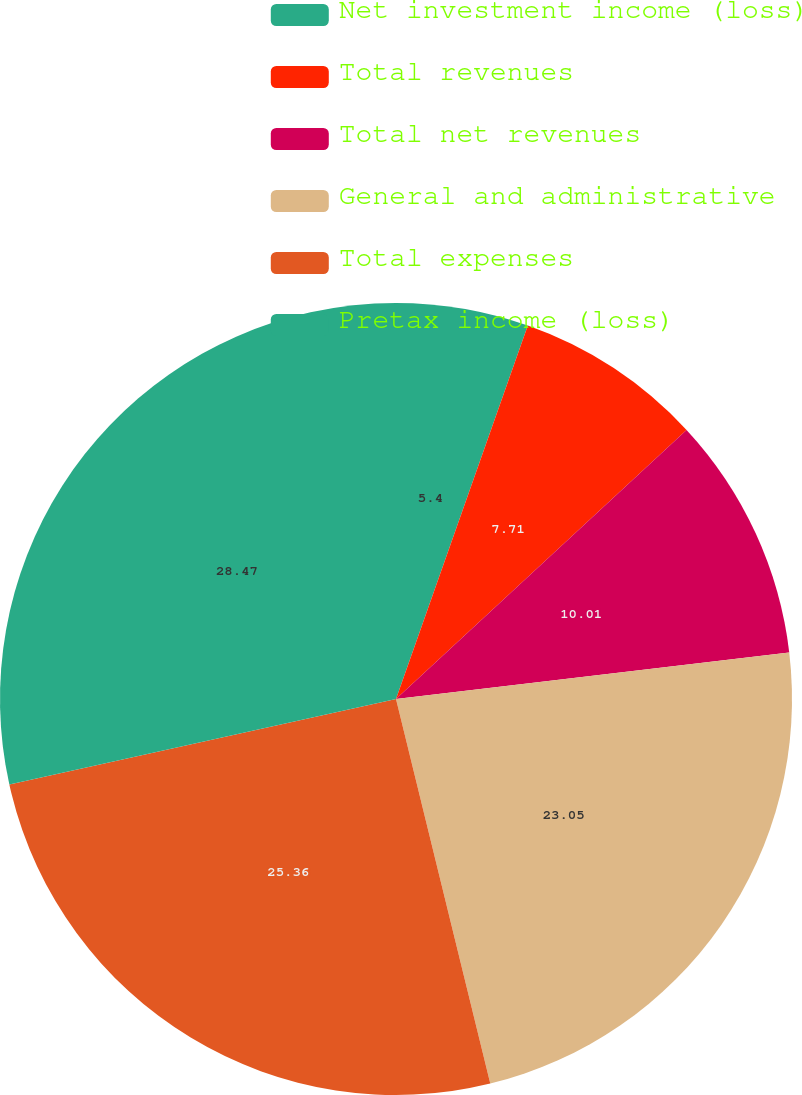Convert chart to OTSL. <chart><loc_0><loc_0><loc_500><loc_500><pie_chart><fcel>Net investment income (loss)<fcel>Total revenues<fcel>Total net revenues<fcel>General and administrative<fcel>Total expenses<fcel>Pretax income (loss)<nl><fcel>5.4%<fcel>7.71%<fcel>10.01%<fcel>23.05%<fcel>25.36%<fcel>28.46%<nl></chart> 